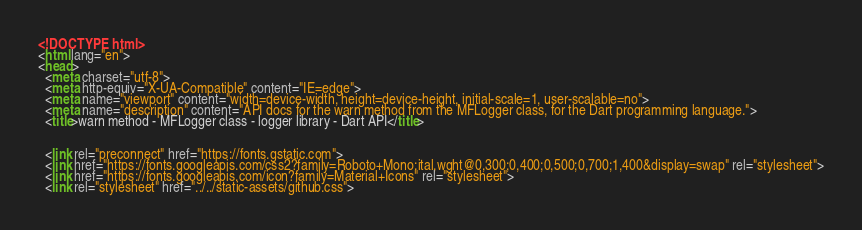Convert code to text. <code><loc_0><loc_0><loc_500><loc_500><_HTML_><!DOCTYPE html>
<html lang="en">
<head>
  <meta charset="utf-8">
  <meta http-equiv="X-UA-Compatible" content="IE=edge">
  <meta name="viewport" content="width=device-width, height=device-height, initial-scale=1, user-scalable=no">
  <meta name="description" content="API docs for the warn method from the MFLogger class, for the Dart programming language.">
  <title>warn method - MFLogger class - logger library - Dart API</title>

  
  <link rel="preconnect" href="https://fonts.gstatic.com">
  <link href="https://fonts.googleapis.com/css2?family=Roboto+Mono:ital,wght@0,300;0,400;0,500;0,700;1,400&display=swap" rel="stylesheet">
  <link href="https://fonts.googleapis.com/icon?family=Material+Icons" rel="stylesheet">
  <link rel="stylesheet" href="../../static-assets/github.css"></code> 